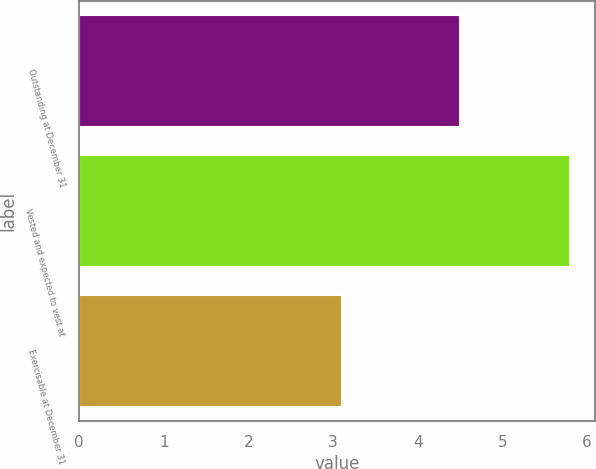Convert chart. <chart><loc_0><loc_0><loc_500><loc_500><bar_chart><fcel>Outstanding at December 31<fcel>Vested and expected to vest at<fcel>Exercisable at December 31<nl><fcel>4.5<fcel>5.8<fcel>3.1<nl></chart> 